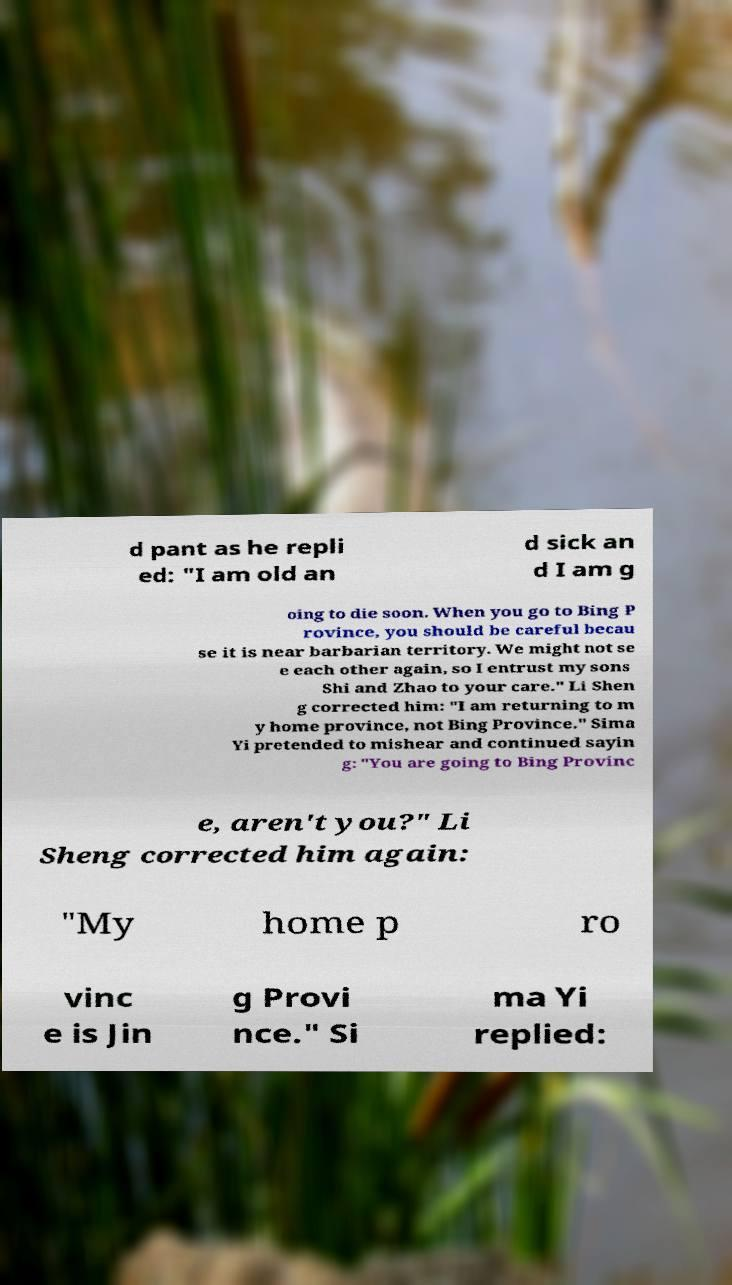Please identify and transcribe the text found in this image. d pant as he repli ed: "I am old an d sick an d I am g oing to die soon. When you go to Bing P rovince, you should be careful becau se it is near barbarian territory. We might not se e each other again, so I entrust my sons Shi and Zhao to your care." Li Shen g corrected him: "I am returning to m y home province, not Bing Province." Sima Yi pretended to mishear and continued sayin g: "You are going to Bing Provinc e, aren't you?" Li Sheng corrected him again: "My home p ro vinc e is Jin g Provi nce." Si ma Yi replied: 